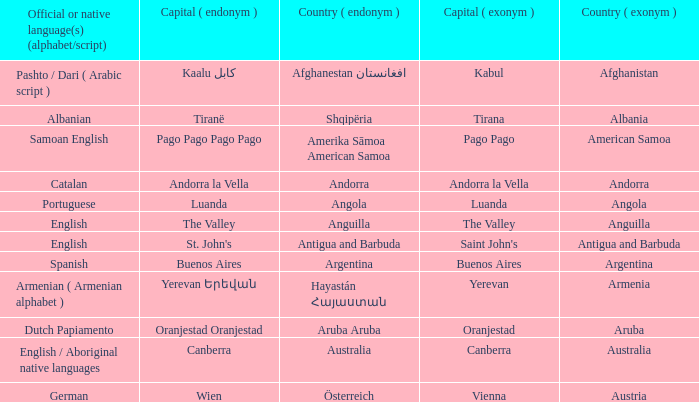How many capital cities does Australia have? 1.0. 